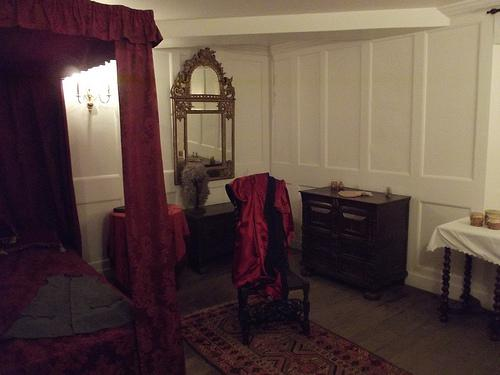Question: where was this photo taken?
Choices:
A. In the lobby.
B. In a hotel room.
C. At the bar.
D. By the pool.
Answer with the letter. Answer: B Question: what is in the photo?
Choices:
A. A bed.
B. Food.
C. A bird.
D. A dog.
Answer with the letter. Answer: A Question: what else is in the room?
Choices:
A. A bed.
B. Food.
C. A mirror.
D. A dog.
Answer with the letter. Answer: C Question: who is in the photo?
Choices:
A. Nobody.
B. Girls.
C. Two boys.
D. A couple.
Answer with the letter. Answer: A 